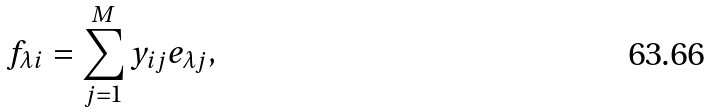Convert formula to latex. <formula><loc_0><loc_0><loc_500><loc_500>f _ { \lambda i } = \sum _ { j = 1 } ^ { M } y _ { i j } e _ { \lambda j } ,</formula> 